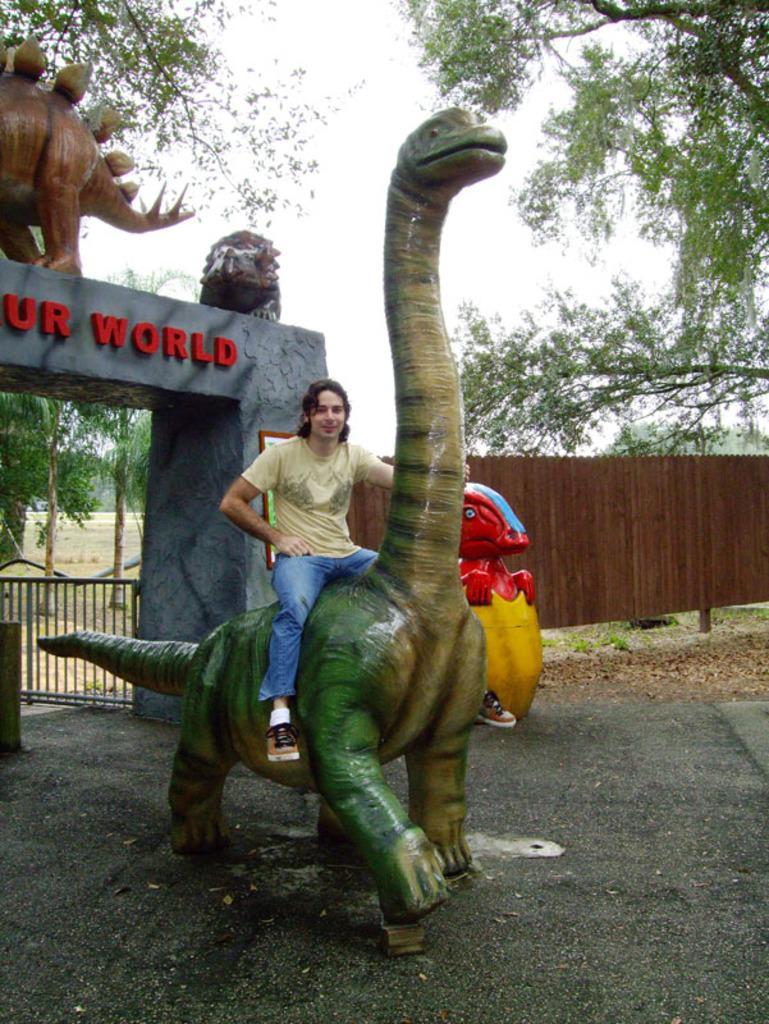Could you give a brief overview of what you see in this image? In the center of the image we can see a man sitting on the sculpture. On the left there is an arch and a gate. In the background we can see a fence, trees and sky. 